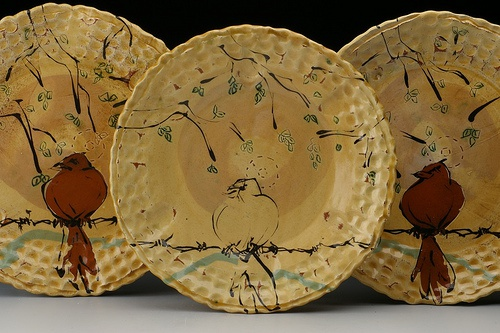Describe the objects in this image and their specific colors. I can see bird in black and olive tones and bird in black, maroon, and olive tones in this image. 